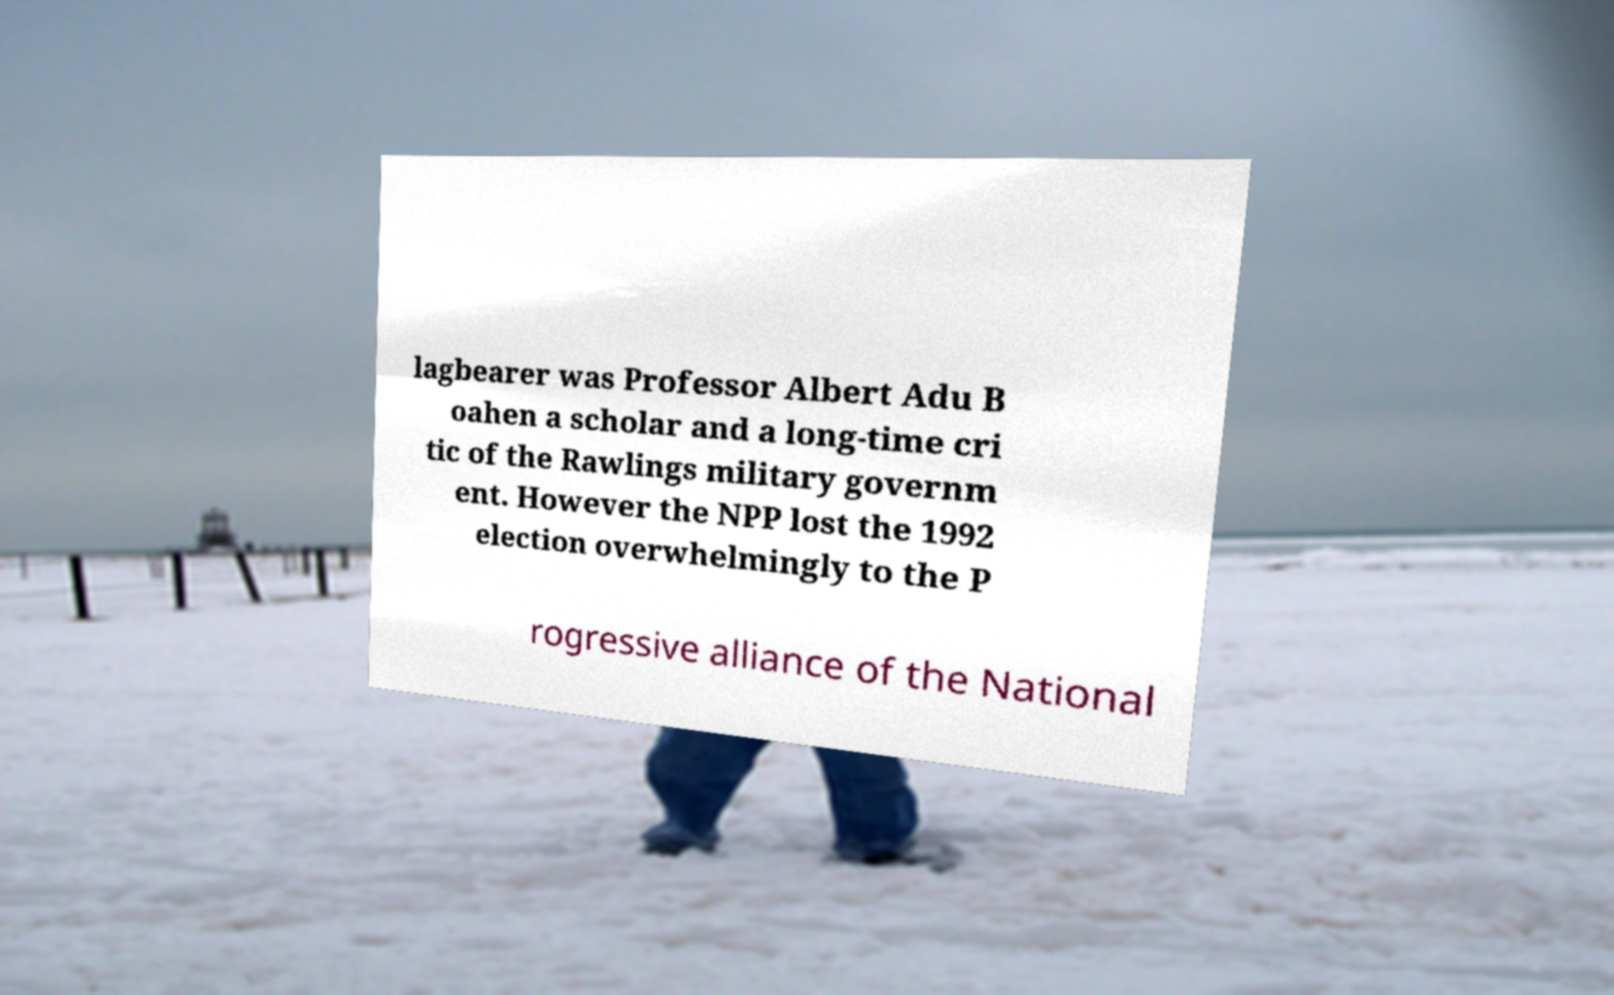There's text embedded in this image that I need extracted. Can you transcribe it verbatim? lagbearer was Professor Albert Adu B oahen a scholar and a long-time cri tic of the Rawlings military governm ent. However the NPP lost the 1992 election overwhelmingly to the P rogressive alliance of the National 